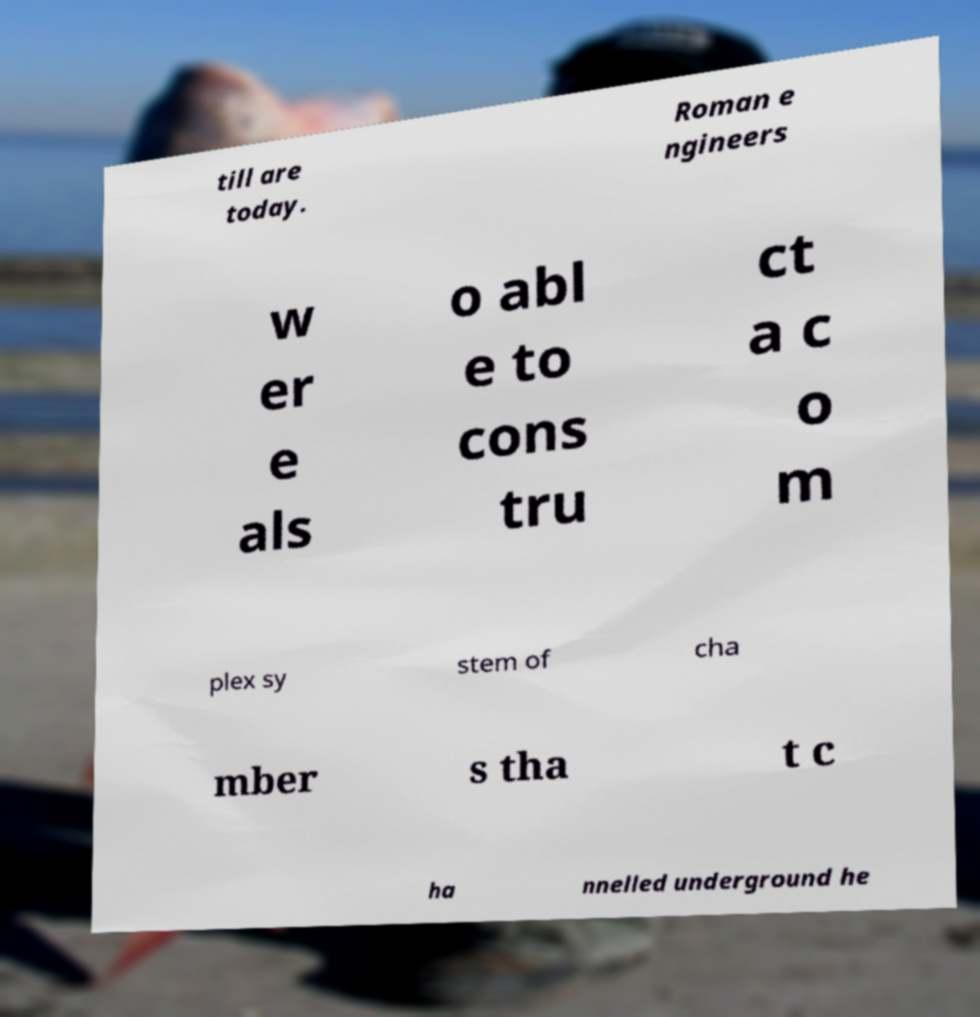Can you read and provide the text displayed in the image?This photo seems to have some interesting text. Can you extract and type it out for me? till are today. Roman e ngineers w er e als o abl e to cons tru ct a c o m plex sy stem of cha mber s tha t c ha nnelled underground he 